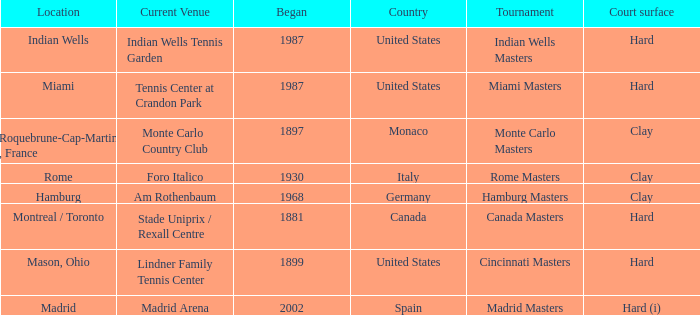Which current venues location is Mason, Ohio? Lindner Family Tennis Center. 